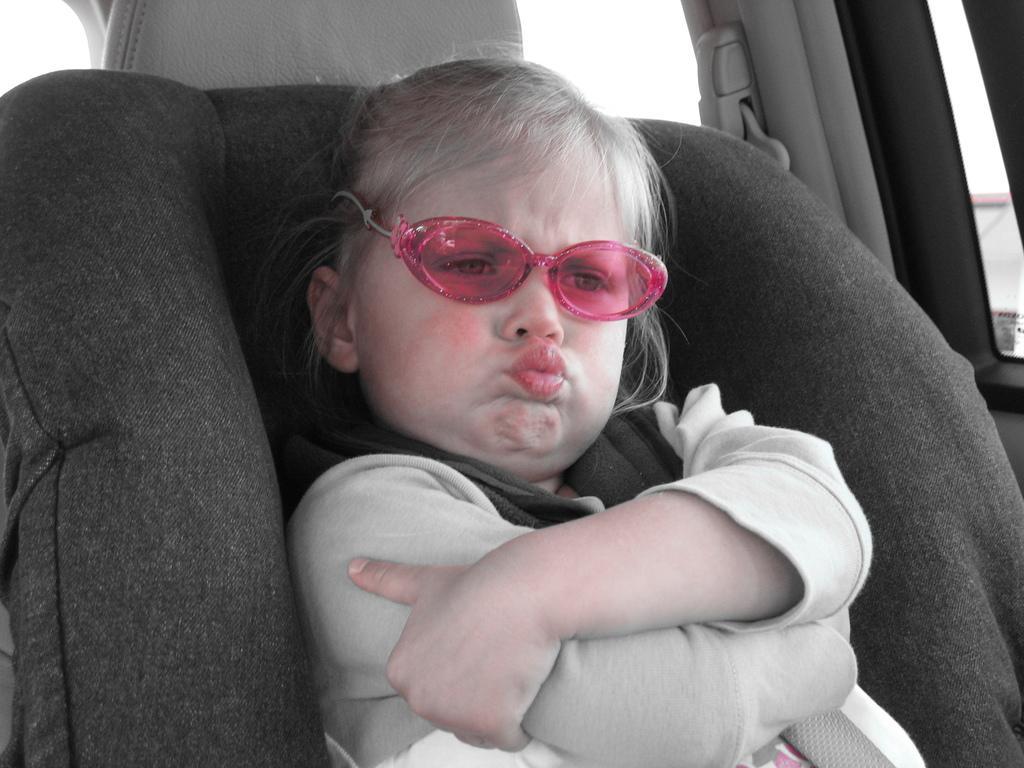Could you give a brief overview of what you see in this image? In the image there is a baby with white dress is sitting on a seat. She is sitting inside a vehicle. 